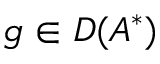Convert formula to latex. <formula><loc_0><loc_0><loc_500><loc_500>g \in D ( A ^ { * } )</formula> 